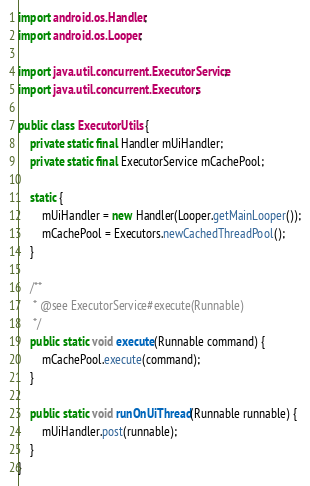Convert code to text. <code><loc_0><loc_0><loc_500><loc_500><_Java_>
import android.os.Handler;
import android.os.Looper;

import java.util.concurrent.ExecutorService;
import java.util.concurrent.Executors;

public class ExecutorUtils {
    private static final Handler mUiHandler;
    private static final ExecutorService mCachePool;

    static {
        mUiHandler = new Handler(Looper.getMainLooper());
        mCachePool = Executors.newCachedThreadPool();
    }

    /**
     * @see ExecutorService#execute(Runnable)
     */
    public static void execute(Runnable command) {
        mCachePool.execute(command);
    }

    public static void runOnUiThread(Runnable runnable) {
        mUiHandler.post(runnable);
    }
}
</code> 